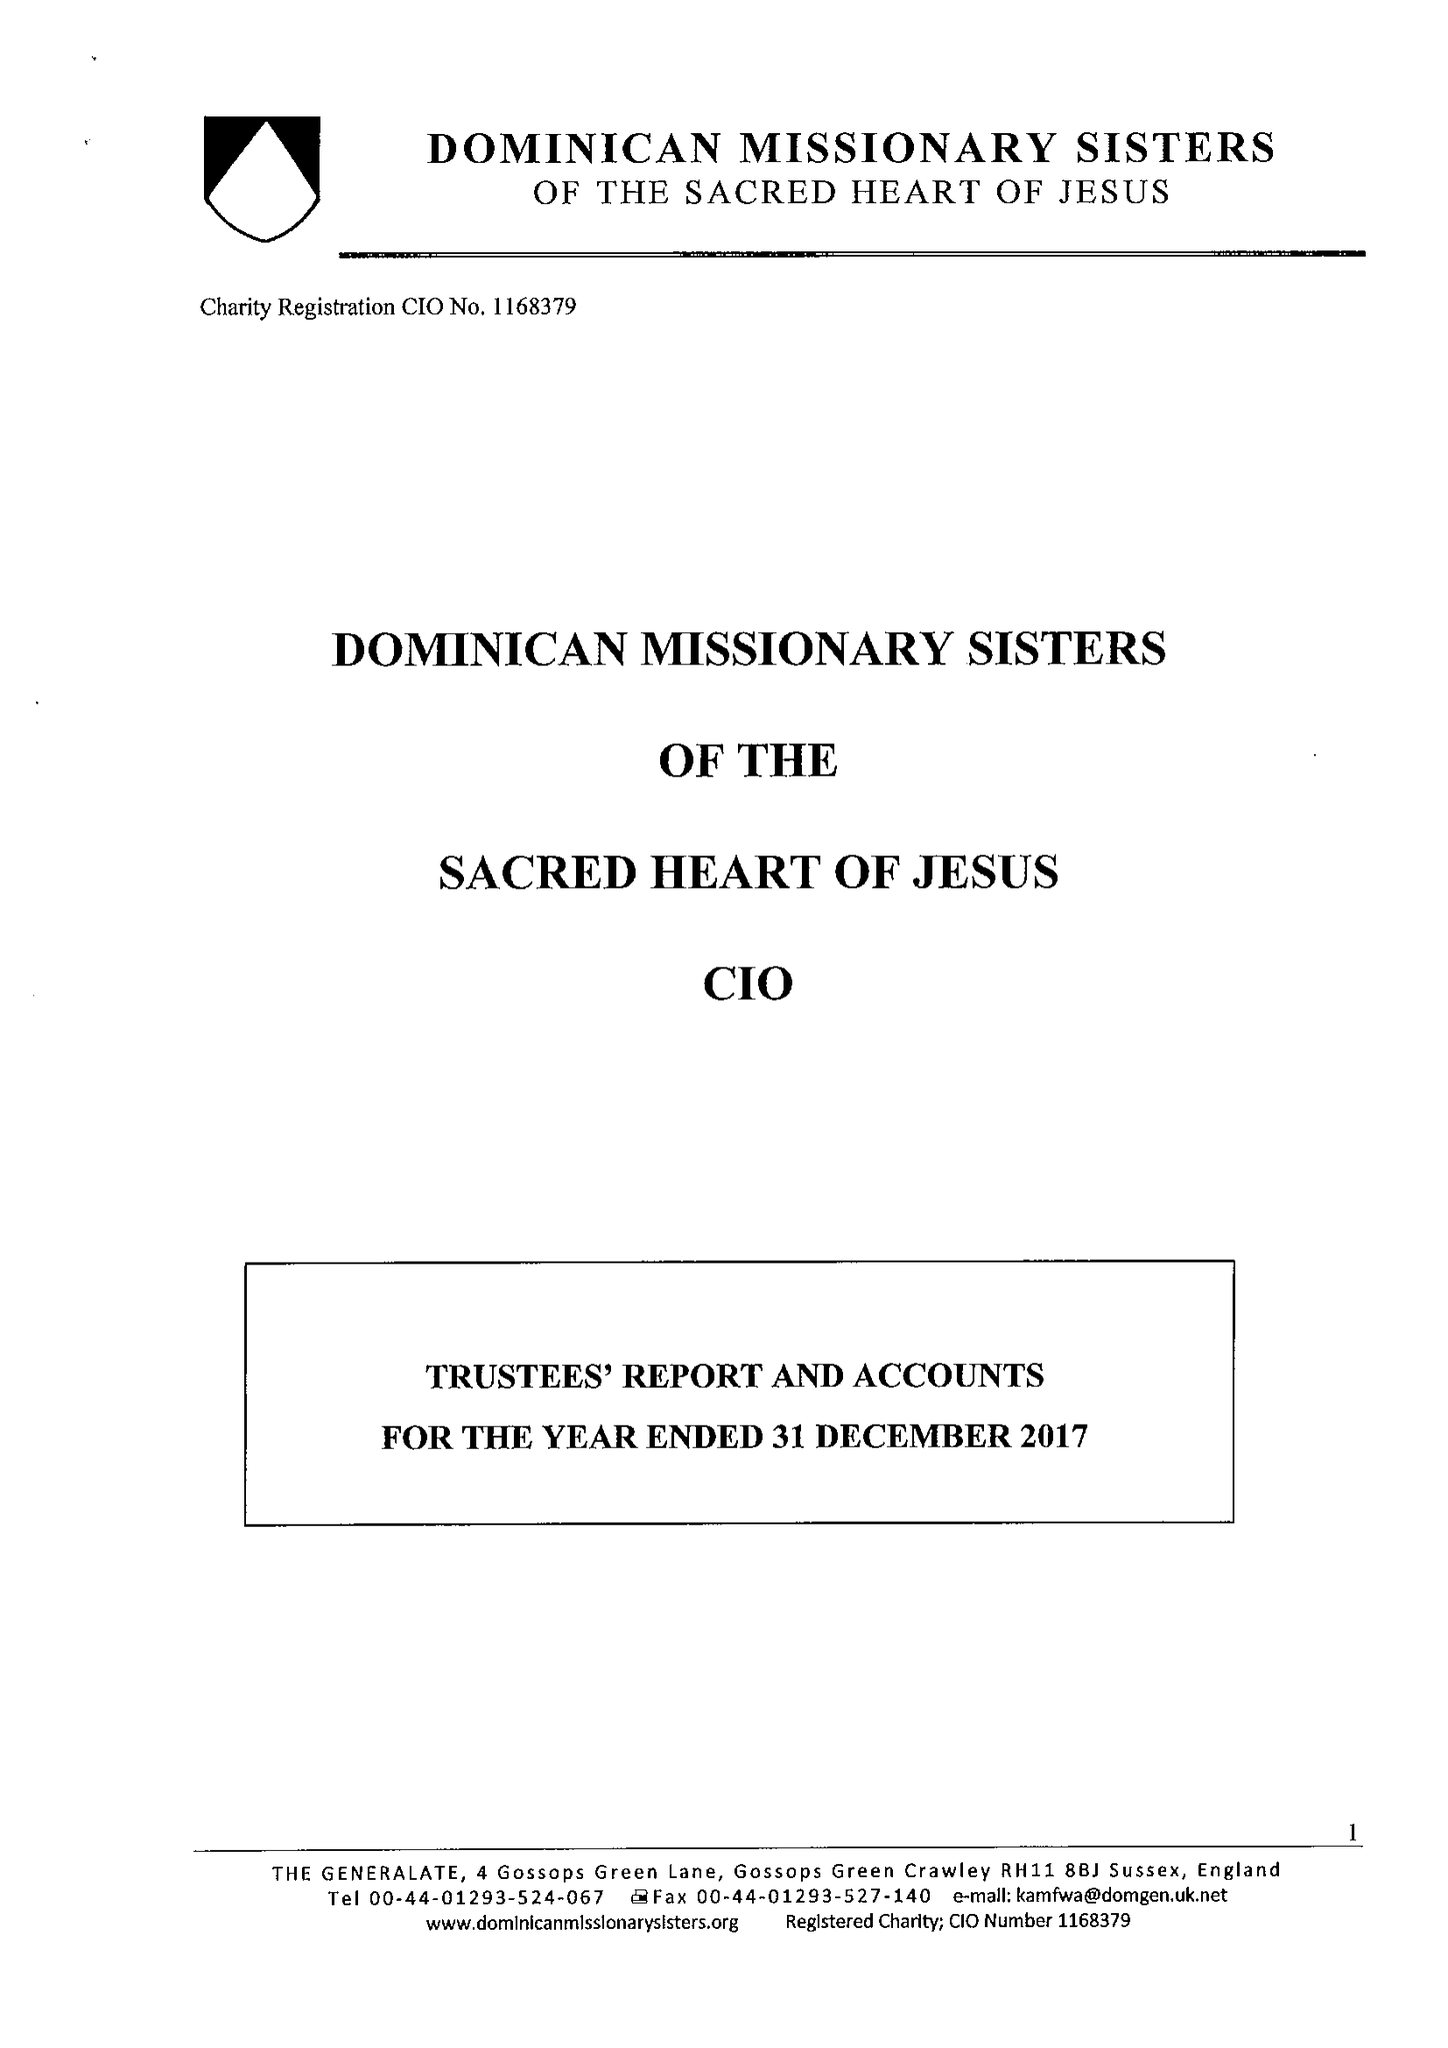What is the value for the spending_annually_in_british_pounds?
Answer the question using a single word or phrase. 218505.00 